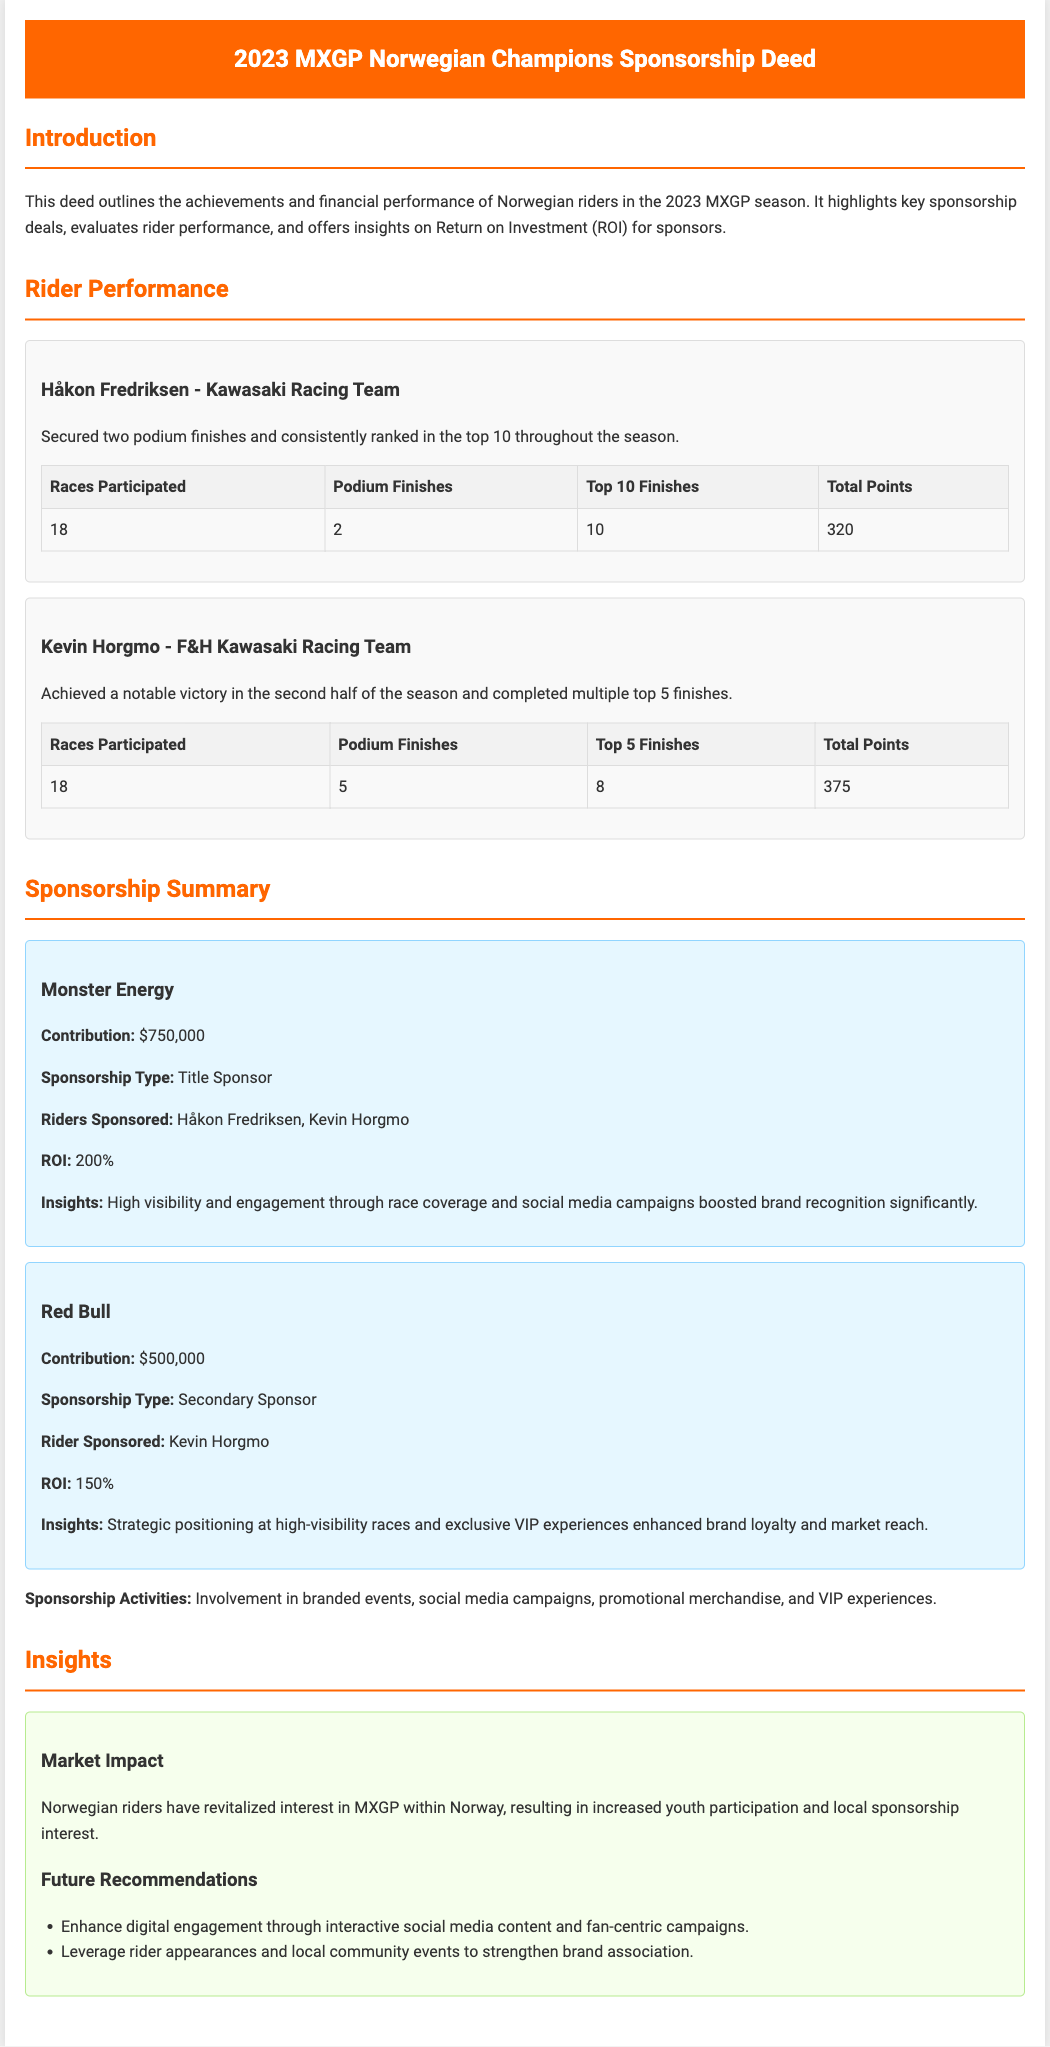what is the name of the first rider mentioned? The document lists Håkon Fredriksen as the first rider in the Rider Performance section.
Answer: Håkon Fredriksen how many podium finishes did Kevin Horgmo achieve? Kevin Horgmo's performance details indicate he had 5 podium finishes.
Answer: 5 what was the total points for Håkon Fredriksen? The total points for Håkon Fredriksen are noted as 320 in the document.
Answer: 320 what is the ROI for Monster Energy? The document specifies that the ROI for Monster Energy is 200%.
Answer: 200% how many races did Kevin Horgmo participate in? The performance data shows that Kevin Horgmo participated in 18 races during the season.
Answer: 18 what sponsorship type did Red Bull have? The document categorizes Red Bull as a Secondary Sponsor.
Answer: Secondary Sponsor what insights were gained from the Monster Energy sponsorship? Insights indicate that Monster Energy achieved high visibility and engagement through race coverage and social media.
Answer: High visibility and engagement what is a recommendation for enhancing digital engagement? The document suggests enhancing digital engagement through interactive social media content.
Answer: Interactive social media content 